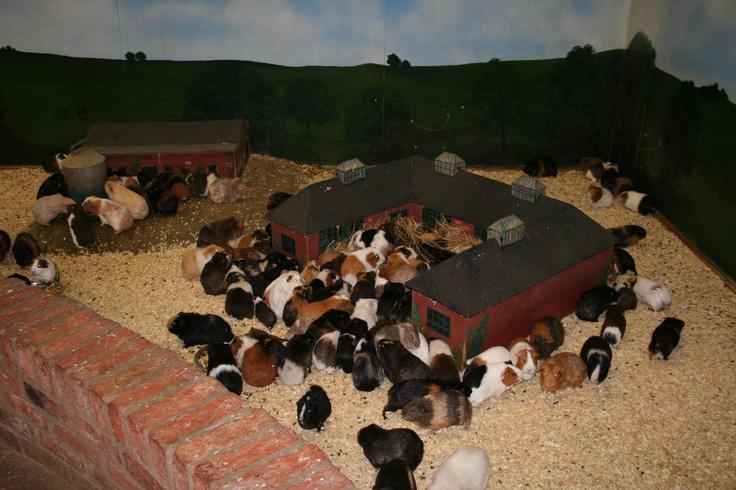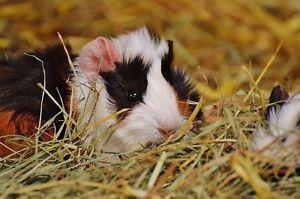The first image is the image on the left, the second image is the image on the right. For the images shown, is this caption "Left image shows tan and white hamsters with green leafy items to eat in front of them." true? Answer yes or no. No. The first image is the image on the left, the second image is the image on the right. For the images shown, is this caption "There are exactly six guinea pigs in the left image and some of them are eating." true? Answer yes or no. No. 